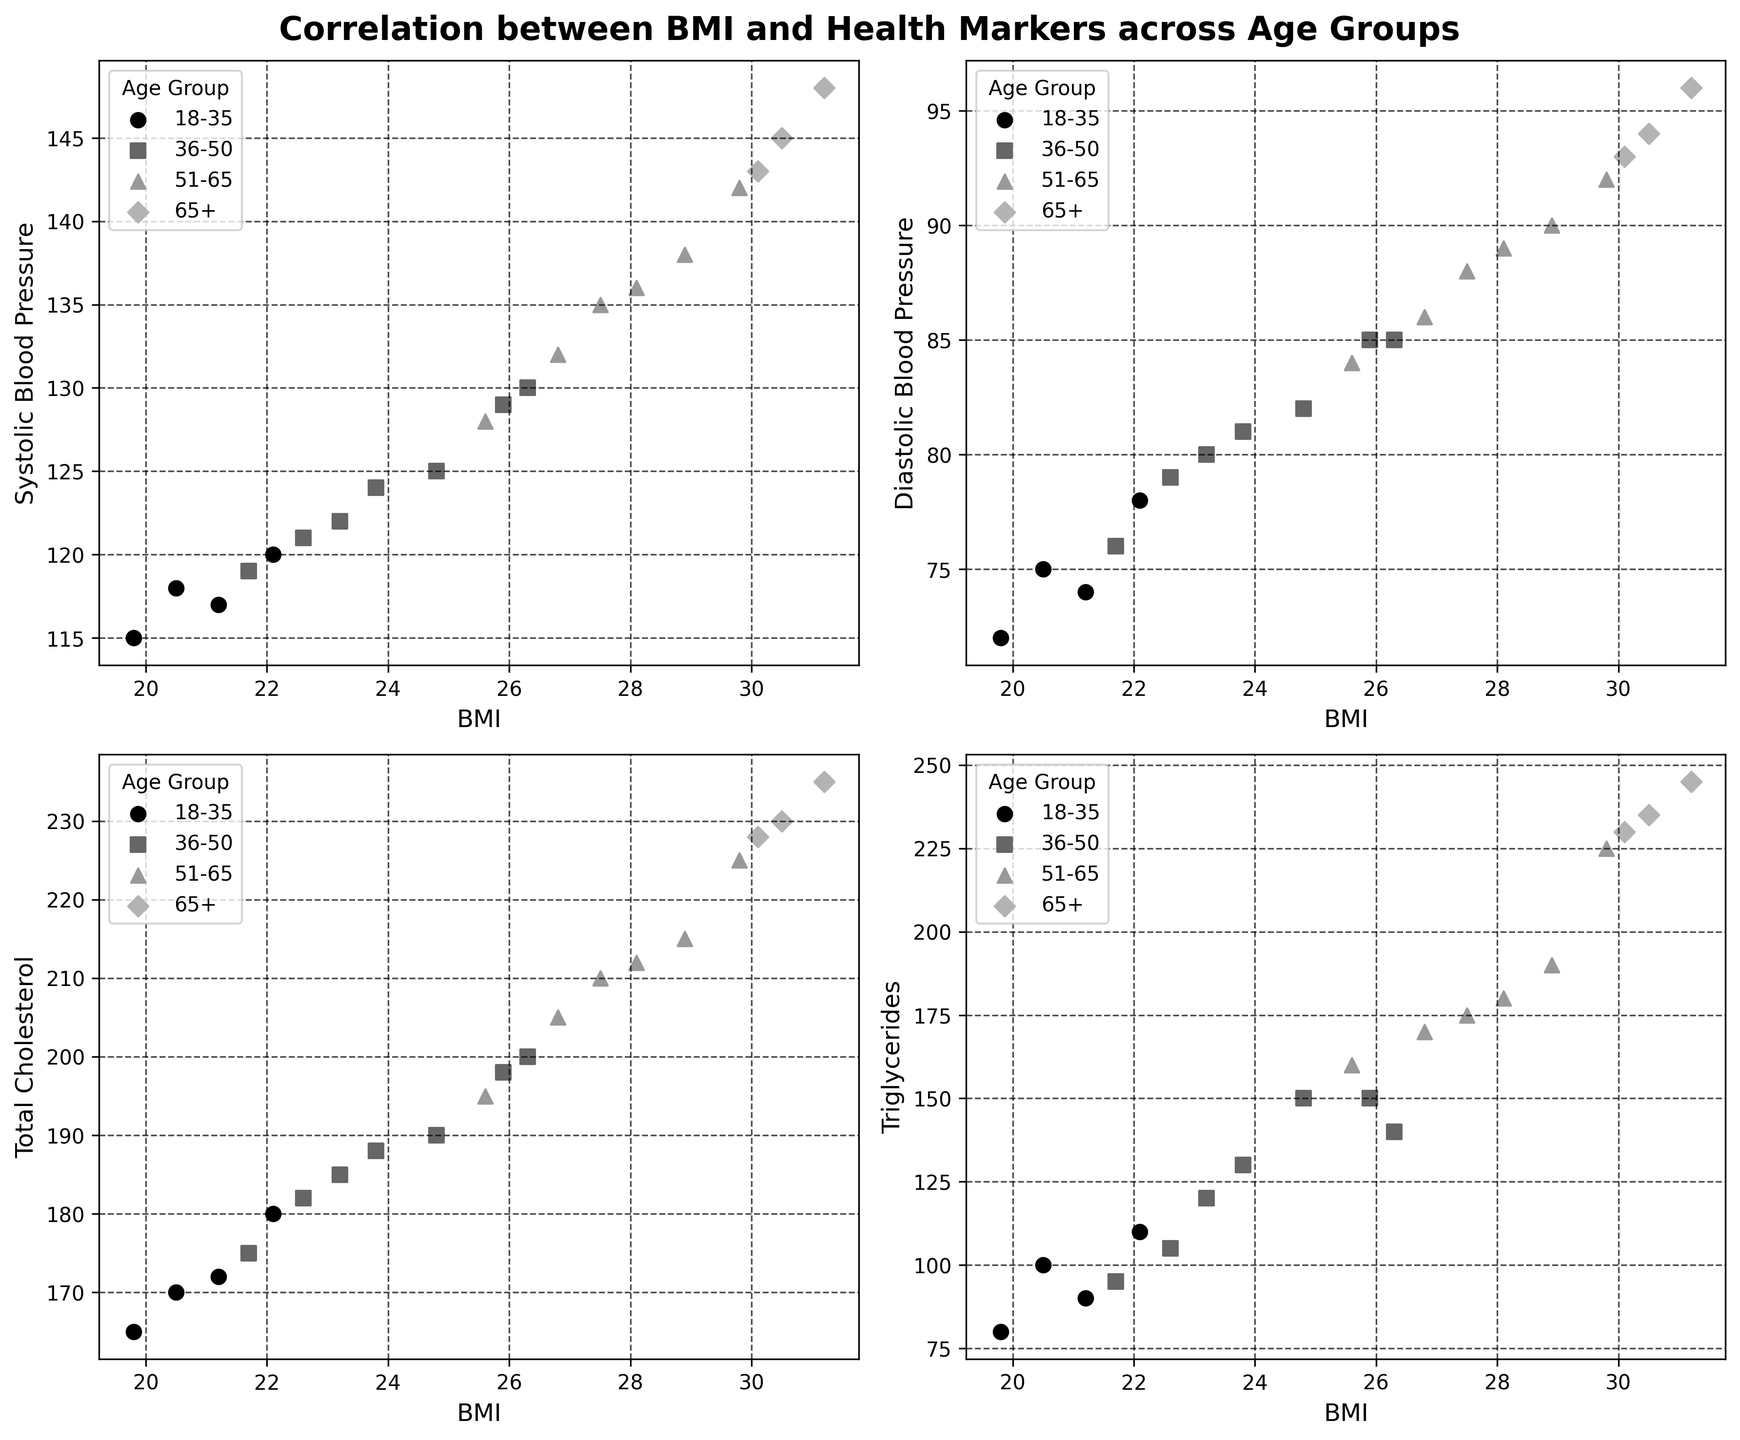What is the title of the figure? The title is typically located at the top of the figure and summarizes the main topic of the visual data. In this case, the title should describe the correlation between BMI and various health markers across age groups.
Answer: Correlation between BMI and Health Markers across Age Groups Which health marker is plotted against BMI in the top-left subplot? The labels on the axes will indicate what is being plotted. For the top-left subplot, the x-axis is labeled "BMI", and the y-axis is labeled with the specific health marker we're interested in.
Answer: Systolic Blood Pressure How many age groups are represented in each subplot? The legend titled "Age Group" lists the different age groups being compared. Count the different entries to determine the number of groups.
Answer: Four In the top-right subplot, which age group has the data points with the highest BMI values? Examine the data points on the subplot and look at the legend to match the age group with the data points' symbols. The group with symbols corresponding to the highest BMI values holds your answer.
Answer: 65+ Is there a general trend between BMI and Systolic Blood Pressure for the age group 51-65? Identify the data points corresponding to the 51-65 age group in the top-left subplot and observe if the data points show an increasing or decreasing trend. Answer whether the relationship is positive, negative, or no clear trend.
Answer: Positive trend What is the range of Triglyceride levels for the 36-50 age group in the bottom-right subplot? Locate the data points for the 36-50 age group, and identify the minimum and maximum y-values to determine the range.
Answer: 120 to 190 In the bottom-left subplot, which age group has the lowest Total Cholesterol levels? Check the data points in the bottom-left subplot and refer to the legend to determine which age group corresponds to the lowest y-values for Total Cholesterol.
Answer: 18-35 Compare the correlation between BMI and Diastolic Blood Pressure for the age groups 18-35 and 65+. Which age group shows a stronger positive correlation? Analyze the scatter of data points for both age groups in the top-right subplot. Look at how tightly the points are clustered in a rising trendline to judge the strength of the correlation.
Answer: 65+ What is the overall shape of the trend between BMI and Triglycerides for all age groups combined in the bottom-right subplot? Examine the overall distribution of data points in the bottom-right subplot to identify if the trend is generally linear, quadratic, logarithmic, etc.
Answer: Linear Between Systolic Blood Pressure and Total Cholesterol, which health marker seems more strongly correlated with BMI across age groups in the respective subplots? Compare the spread and direction of the data points in the top-left subplot (Systolic BP) and bottom-left subplot (Total Cholesterol). Determine which subplot shows a more consistent trend.
Answer: Systolic Blood Pressure 